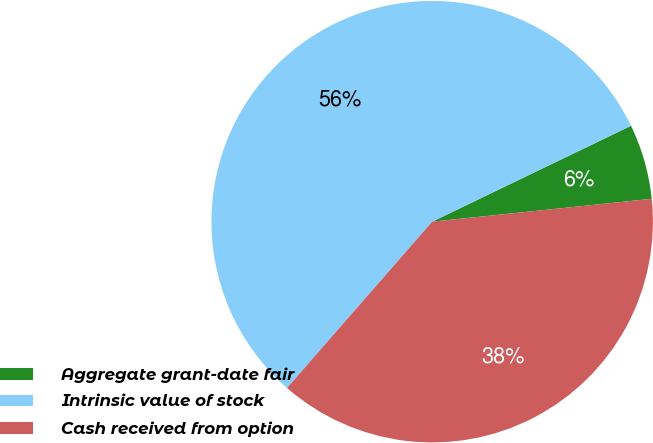Convert chart to OTSL. <chart><loc_0><loc_0><loc_500><loc_500><pie_chart><fcel>Aggregate grant-date fair<fcel>Intrinsic value of stock<fcel>Cash received from option<nl><fcel>5.5%<fcel>56.42%<fcel>38.07%<nl></chart> 